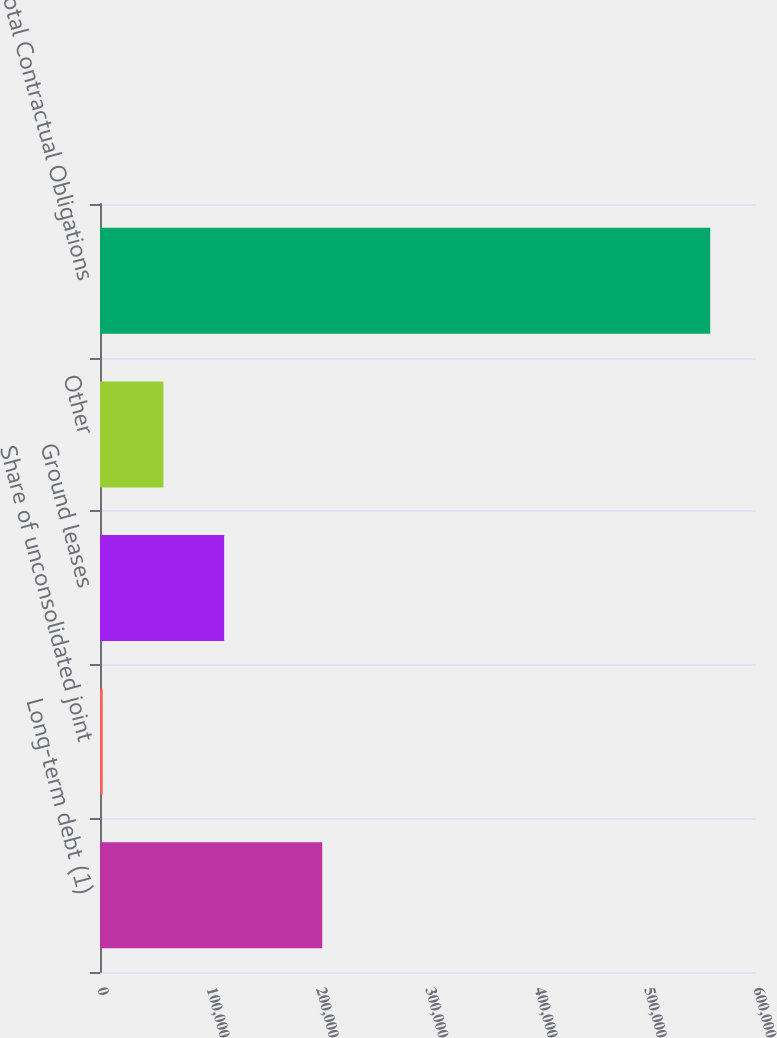Convert chart. <chart><loc_0><loc_0><loc_500><loc_500><bar_chart><fcel>Long-term debt (1)<fcel>Share of unconsolidated joint<fcel>Ground leases<fcel>Other<fcel>Total Contractual Obligations<nl><fcel>203244<fcel>2444<fcel>113583<fcel>58013.4<fcel>558138<nl></chart> 